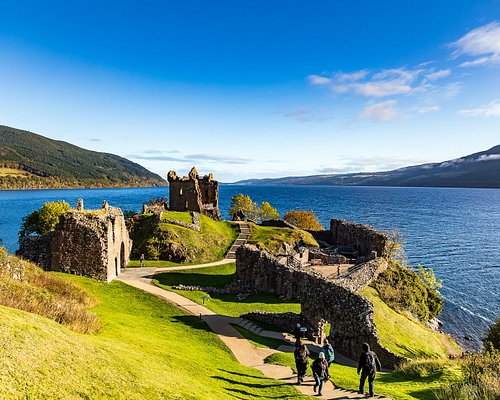Describe the following image. The image vividly captures the ancient ruins of Urquhart Castle, which proudly stands on a lush, green slope descending toward the expansive Loch Ness in Scotland. Constructed from rugged stone, the castle's remnants narrate tales of bygone eras under the open blue sky, paralleled by the deep blue-green waters below. Various paths meander around the ruins, inviting visitors to wander through layers of history and savor the spectacular views, while a few tourists dot the landscape, emphasizing the castle’s role as a vibrant historical site amidst serene natural beauty. 